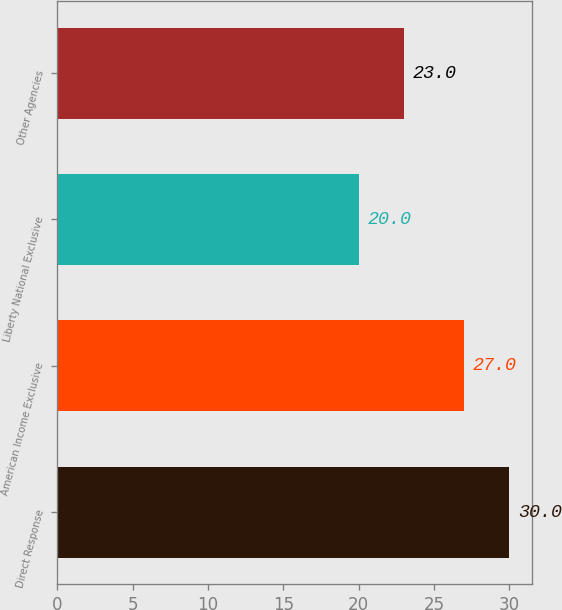Convert chart. <chart><loc_0><loc_0><loc_500><loc_500><bar_chart><fcel>Direct Response<fcel>American Income Exclusive<fcel>Liberty National Exclusive<fcel>Other Agencies<nl><fcel>30<fcel>27<fcel>20<fcel>23<nl></chart> 